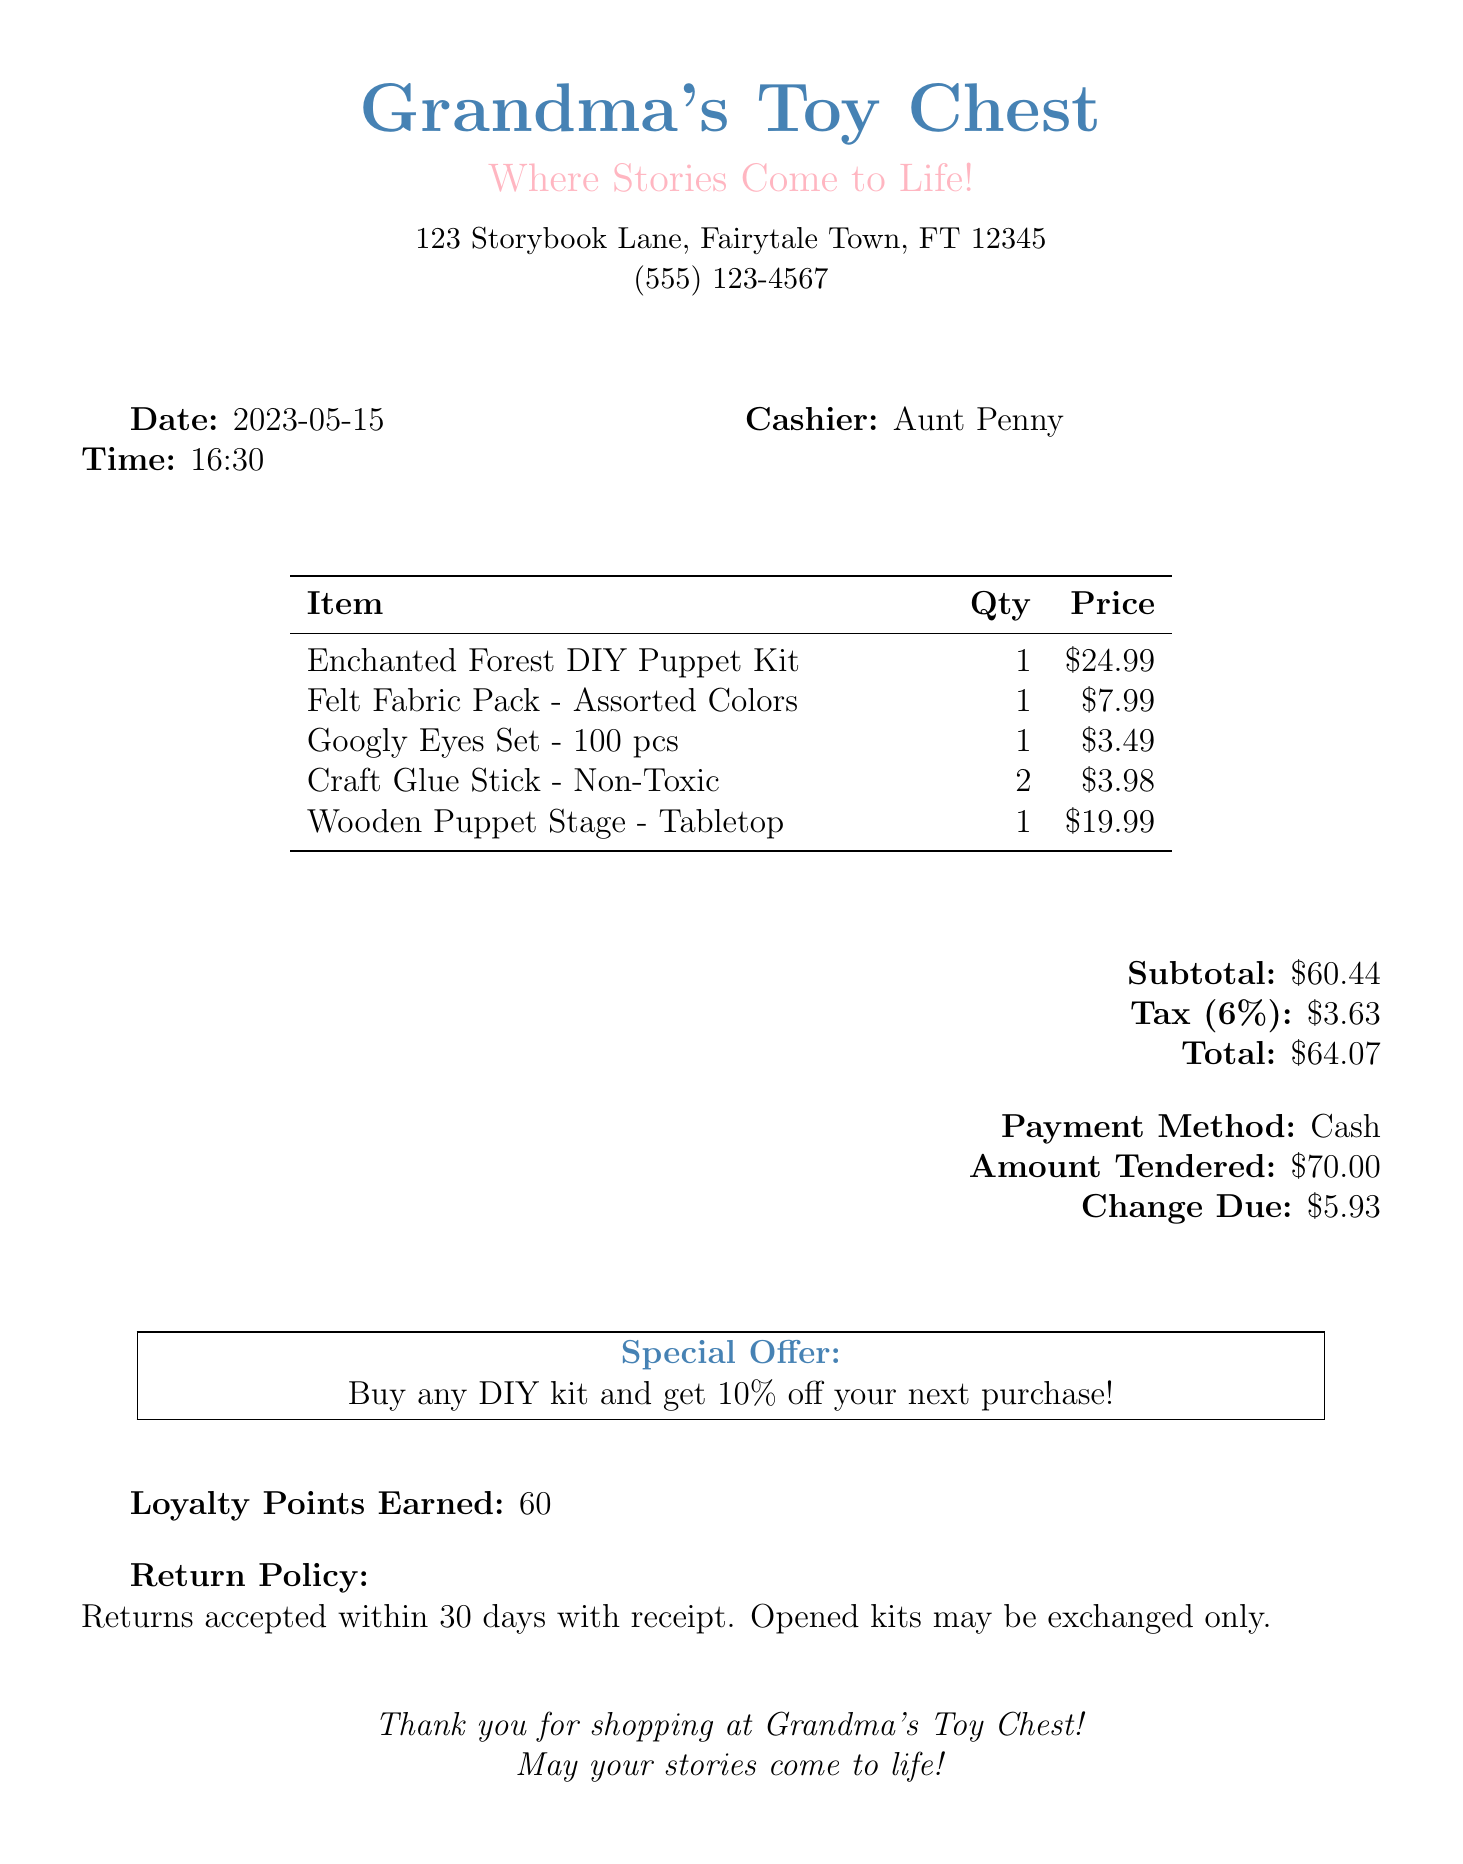What is the name of the store? The store name is listed at the top of the receipt.
Answer: Grandma's Toy Chest What is the date of the purchase? The date is provided in the receipt section indicating when the transaction occurred.
Answer: 2023-05-15 Who was the cashier? The cashier's name is mentioned in a specific section of the document.
Answer: Aunt Penny What is the total amount? The total amount is calculated and presented in the financial summary at the bottom of the receipt.
Answer: $64.07 How many loyalty points were earned? The receipt includes a line that specifies the loyalty points earned for this transaction.
Answer: 60 What is the price of the Enchanted Forest DIY Puppet Kit? The price for this specific item is clearly outlined in the itemized list.
Answer: $24.99 What is the return policy? The return policy is mentioned towards the end, detailing conditions for returns.
Answer: Returns accepted within 30 days with receipt What special offer is provided? There is a special offer printed within a box on the receipt that encourages future purchases.
Answer: Buy any DIY kit and get 10% off your next purchase! 